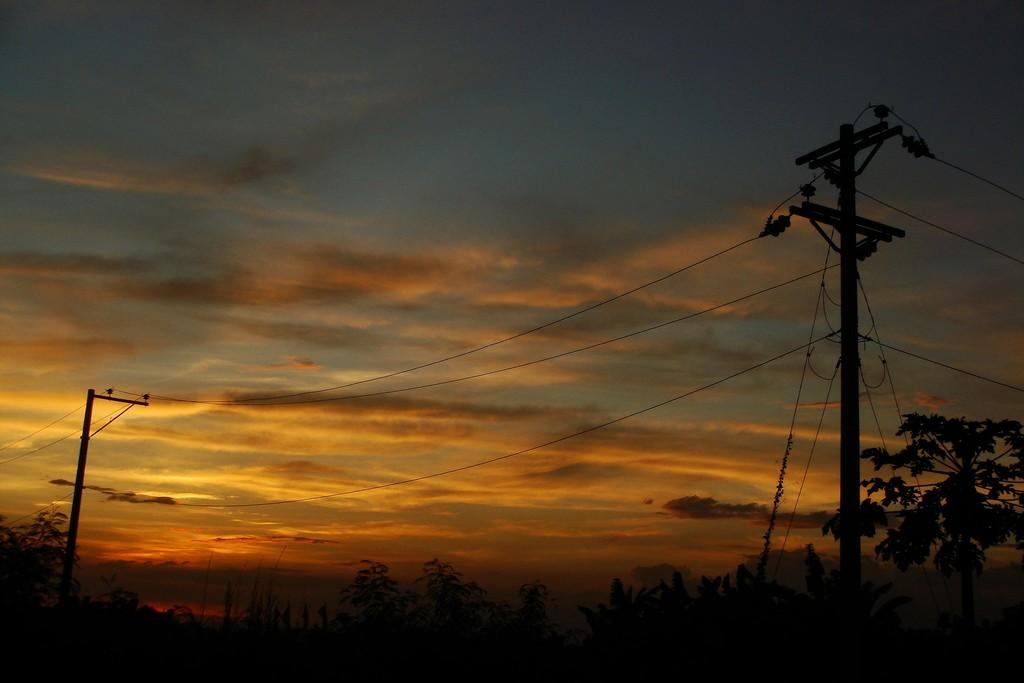Where was the picture taken? The picture was clicked outside. What can be seen in the foreground of the image? There are trees, poles, and cables in the foreground of the image. What is visible in the background of the image? The sky is visible in the background of the image. What can be observed in the sky? Clouds are present in the sky. Is there a bear visible in the image? No, there is no bear present in the image. What type of glass is used to create the image? The image is a photograph, and there is no glass involved in its creation. 